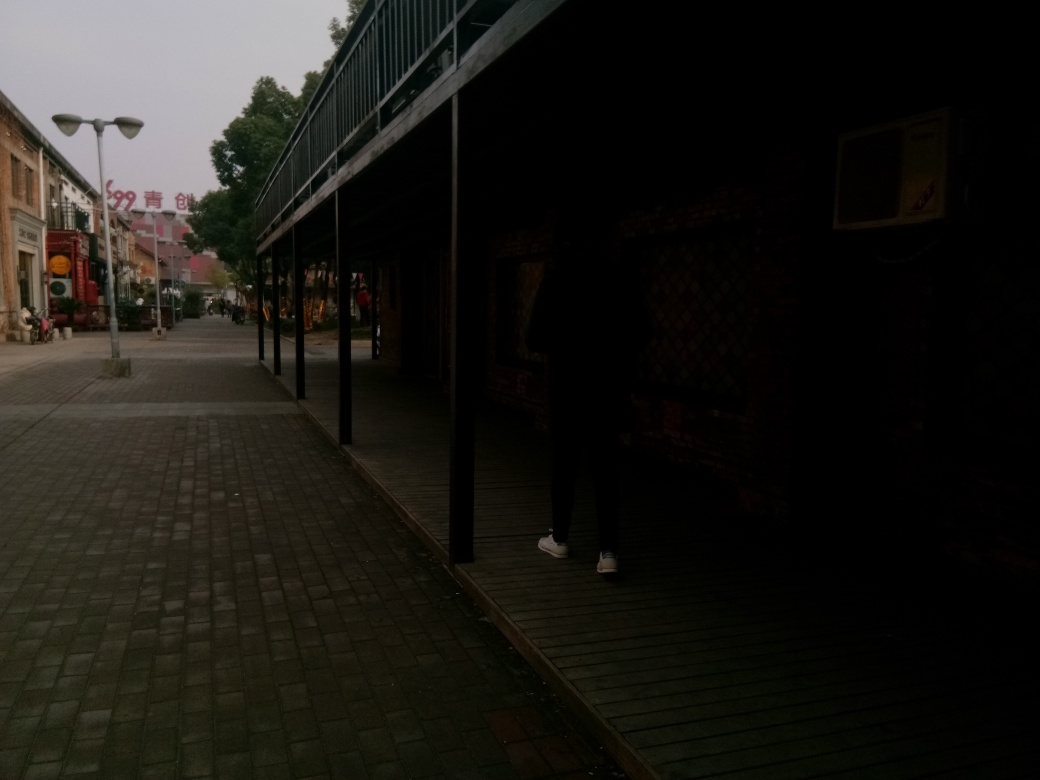Could you describe the pedestrian activity in the scene? The pedestrian activity is minimal, with only a few individuals visible in the distance. This conveys a sense of calmness and possibly indicates a non-peak hour for foot traffic in this area. What does the presence of the covered walkway suggest about the climate or weather patterns in this location? The presence of the covered walkway could indicate a climate with frequent rain or harsh sunlight, where such structures are implemented to protect pedestrians from the elements. 